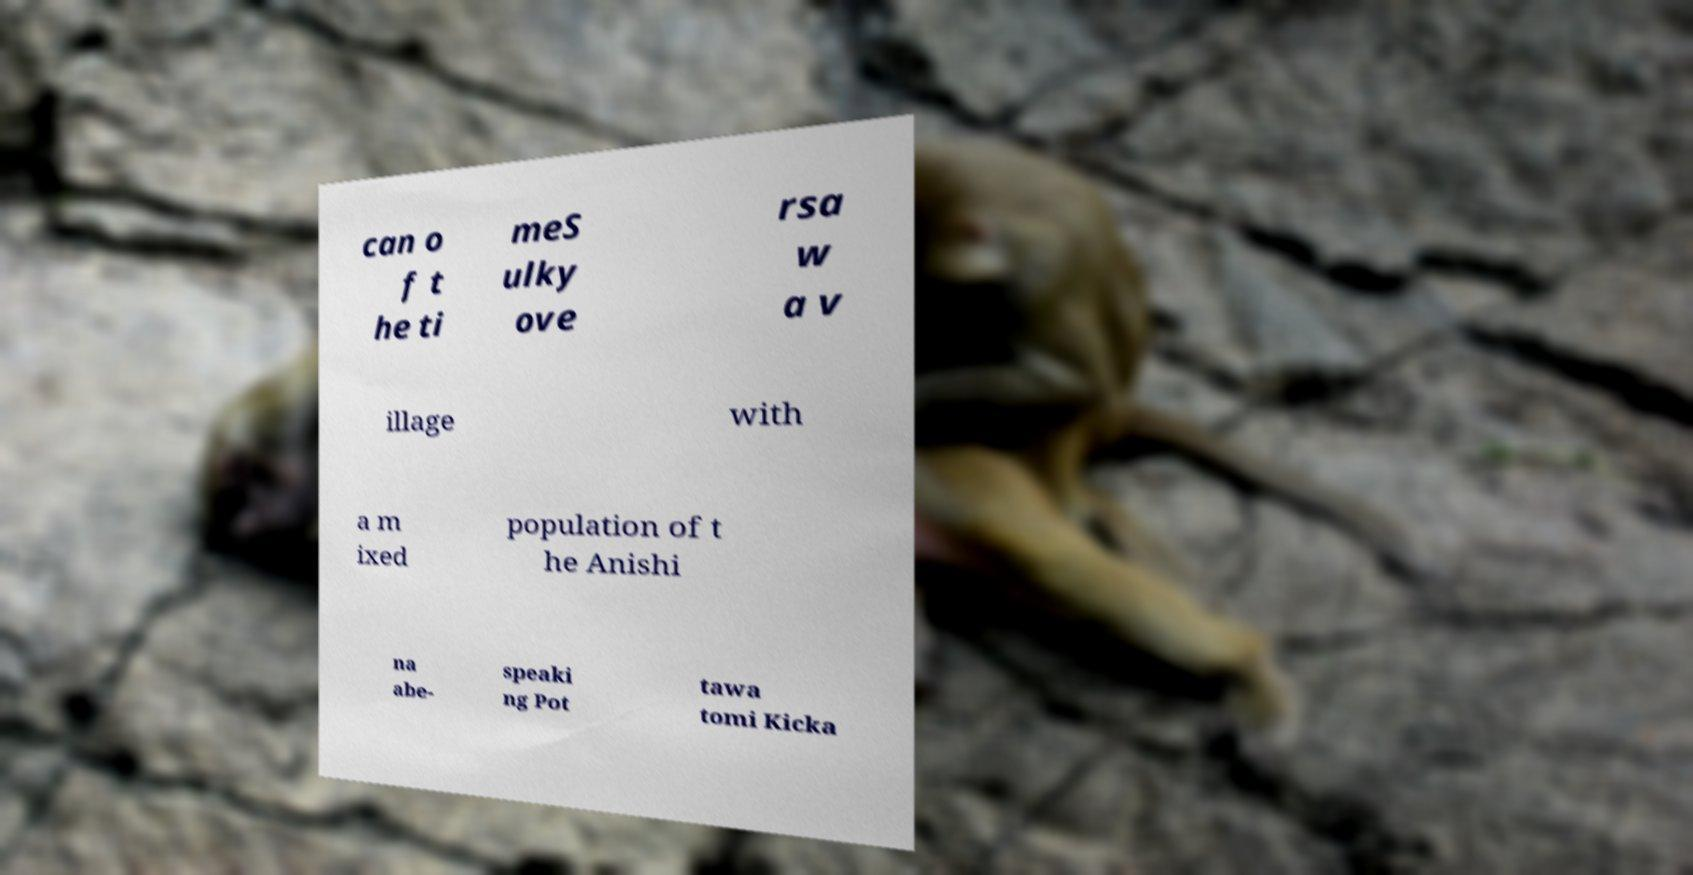I need the written content from this picture converted into text. Can you do that? can o f t he ti meS ulky ove rsa w a v illage with a m ixed population of t he Anishi na abe- speaki ng Pot tawa tomi Kicka 